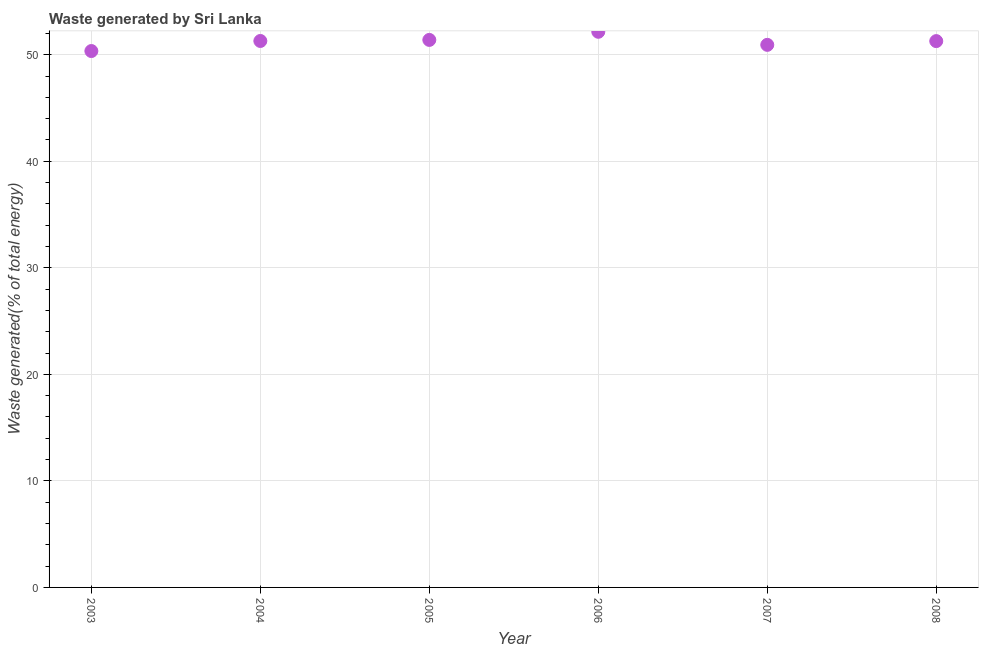What is the amount of waste generated in 2003?
Your answer should be very brief. 50.35. Across all years, what is the maximum amount of waste generated?
Offer a very short reply. 52.16. Across all years, what is the minimum amount of waste generated?
Your answer should be compact. 50.35. What is the sum of the amount of waste generated?
Give a very brief answer. 307.41. What is the difference between the amount of waste generated in 2004 and 2008?
Your answer should be compact. 0.01. What is the average amount of waste generated per year?
Provide a succinct answer. 51.23. What is the median amount of waste generated?
Provide a short and direct response. 51.29. In how many years, is the amount of waste generated greater than 12 %?
Your answer should be very brief. 6. What is the ratio of the amount of waste generated in 2003 to that in 2005?
Make the answer very short. 0.98. Is the difference between the amount of waste generated in 2003 and 2005 greater than the difference between any two years?
Offer a terse response. No. What is the difference between the highest and the second highest amount of waste generated?
Offer a very short reply. 0.76. Is the sum of the amount of waste generated in 2003 and 2007 greater than the maximum amount of waste generated across all years?
Your response must be concise. Yes. What is the difference between the highest and the lowest amount of waste generated?
Provide a short and direct response. 1.81. Does the amount of waste generated monotonically increase over the years?
Provide a succinct answer. No. How many dotlines are there?
Provide a succinct answer. 1. What is the difference between two consecutive major ticks on the Y-axis?
Your answer should be very brief. 10. What is the title of the graph?
Provide a short and direct response. Waste generated by Sri Lanka. What is the label or title of the Y-axis?
Your response must be concise. Waste generated(% of total energy). What is the Waste generated(% of total energy) in 2003?
Make the answer very short. 50.35. What is the Waste generated(% of total energy) in 2004?
Give a very brief answer. 51.29. What is the Waste generated(% of total energy) in 2005?
Offer a terse response. 51.39. What is the Waste generated(% of total energy) in 2006?
Give a very brief answer. 52.16. What is the Waste generated(% of total energy) in 2007?
Ensure brevity in your answer.  50.93. What is the Waste generated(% of total energy) in 2008?
Provide a succinct answer. 51.28. What is the difference between the Waste generated(% of total energy) in 2003 and 2004?
Your answer should be very brief. -0.94. What is the difference between the Waste generated(% of total energy) in 2003 and 2005?
Provide a short and direct response. -1.04. What is the difference between the Waste generated(% of total energy) in 2003 and 2006?
Provide a short and direct response. -1.81. What is the difference between the Waste generated(% of total energy) in 2003 and 2007?
Provide a succinct answer. -0.58. What is the difference between the Waste generated(% of total energy) in 2003 and 2008?
Offer a very short reply. -0.93. What is the difference between the Waste generated(% of total energy) in 2004 and 2005?
Your answer should be very brief. -0.1. What is the difference between the Waste generated(% of total energy) in 2004 and 2006?
Give a very brief answer. -0.86. What is the difference between the Waste generated(% of total energy) in 2004 and 2007?
Ensure brevity in your answer.  0.36. What is the difference between the Waste generated(% of total energy) in 2004 and 2008?
Keep it short and to the point. 0.01. What is the difference between the Waste generated(% of total energy) in 2005 and 2006?
Your response must be concise. -0.76. What is the difference between the Waste generated(% of total energy) in 2005 and 2007?
Keep it short and to the point. 0.46. What is the difference between the Waste generated(% of total energy) in 2005 and 2008?
Your answer should be very brief. 0.11. What is the difference between the Waste generated(% of total energy) in 2006 and 2007?
Provide a short and direct response. 1.23. What is the difference between the Waste generated(% of total energy) in 2006 and 2008?
Your answer should be very brief. 0.87. What is the difference between the Waste generated(% of total energy) in 2007 and 2008?
Your answer should be compact. -0.35. What is the ratio of the Waste generated(% of total energy) in 2003 to that in 2005?
Provide a succinct answer. 0.98. What is the ratio of the Waste generated(% of total energy) in 2003 to that in 2006?
Give a very brief answer. 0.96. What is the ratio of the Waste generated(% of total energy) in 2003 to that in 2008?
Offer a terse response. 0.98. What is the ratio of the Waste generated(% of total energy) in 2004 to that in 2008?
Your answer should be very brief. 1. What is the ratio of the Waste generated(% of total energy) in 2005 to that in 2007?
Make the answer very short. 1.01. What is the ratio of the Waste generated(% of total energy) in 2005 to that in 2008?
Keep it short and to the point. 1. What is the ratio of the Waste generated(% of total energy) in 2006 to that in 2007?
Your response must be concise. 1.02. 